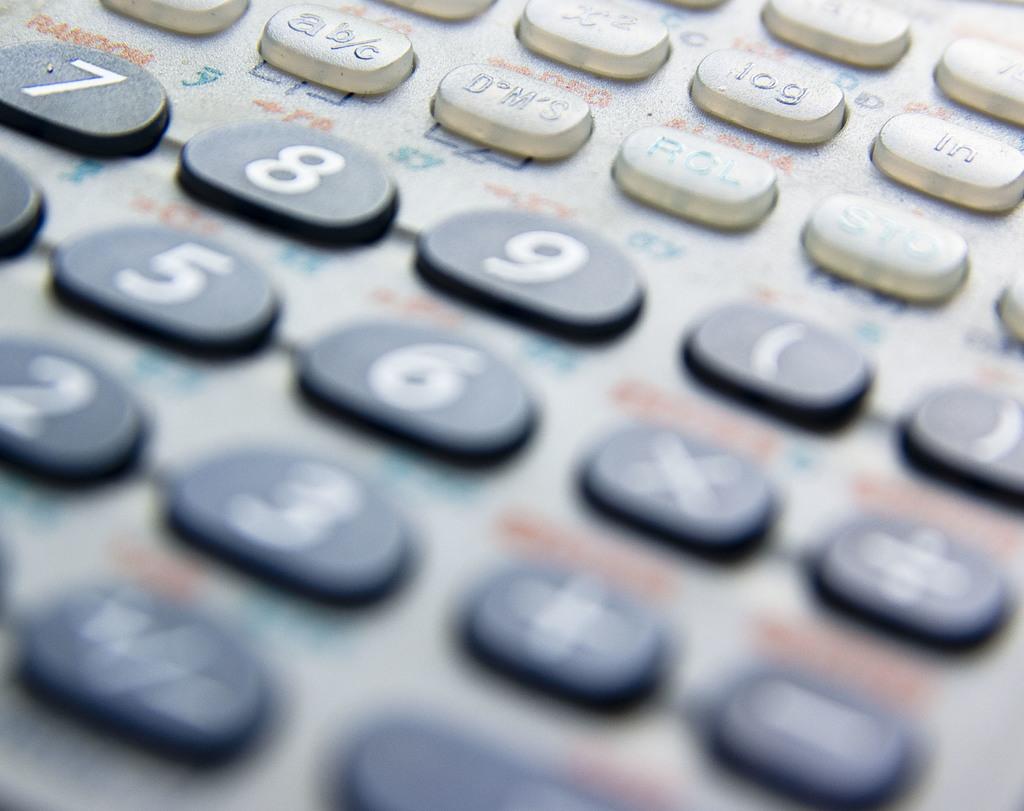What button is beside the log button?
Make the answer very short. Ln. Is this a computer keyboard?
Offer a terse response. Answering does not require reading text in the image. 